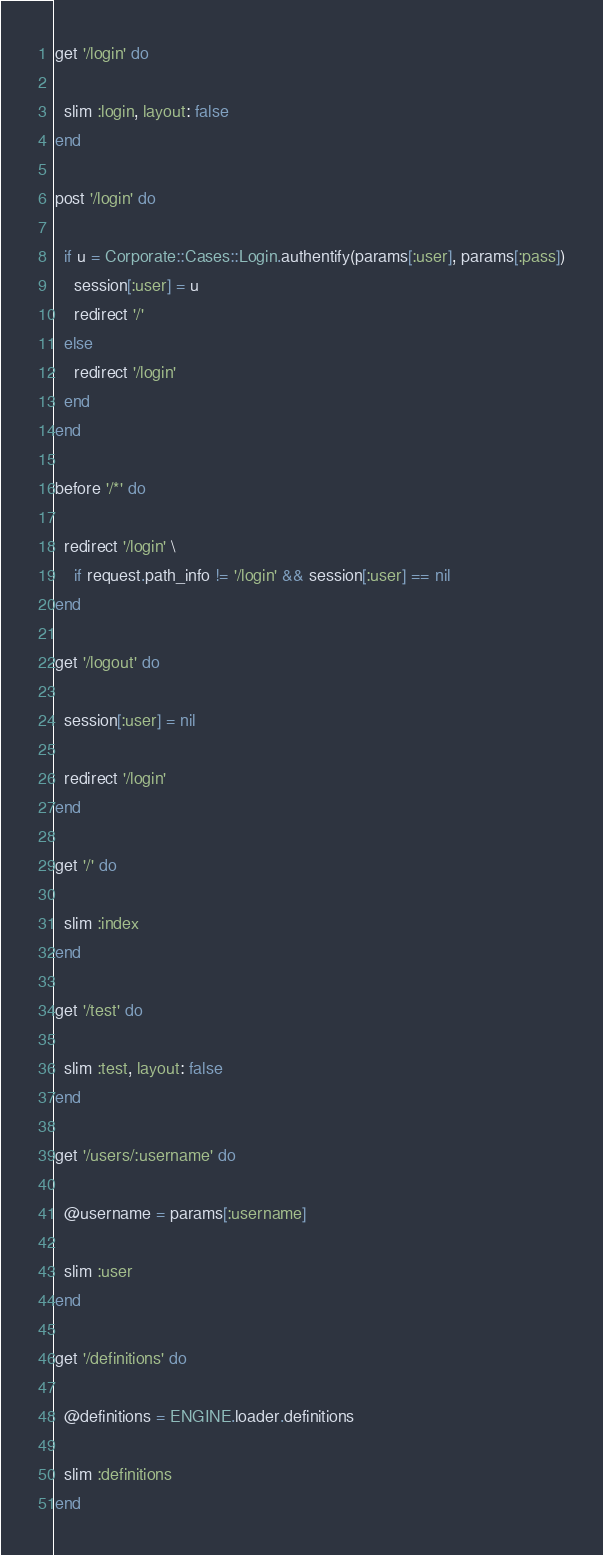<code> <loc_0><loc_0><loc_500><loc_500><_Ruby_>
get '/login' do

  slim :login, layout: false
end

post '/login' do

  if u = Corporate::Cases::Login.authentify(params[:user], params[:pass])
    session[:user] = u
    redirect '/'
  else
    redirect '/login'
  end
end

before '/*' do

  redirect '/login' \
    if request.path_info != '/login' && session[:user] == nil
end

get '/logout' do

  session[:user] = nil

  redirect '/login'
end

get '/' do

  slim :index
end

get '/test' do

  slim :test, layout: false
end

get '/users/:username' do

  @username = params[:username]

  slim :user
end

get '/definitions' do

  @definitions = ENGINE.loader.definitions

  slim :definitions
end

</code> 